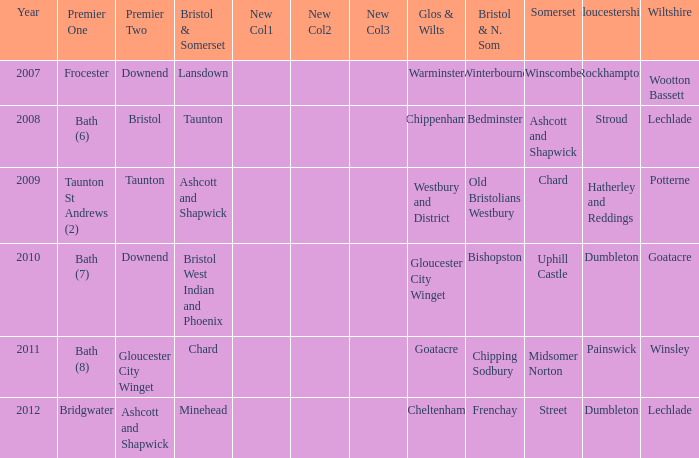What is the somerset for the  year 2009? Chard. 